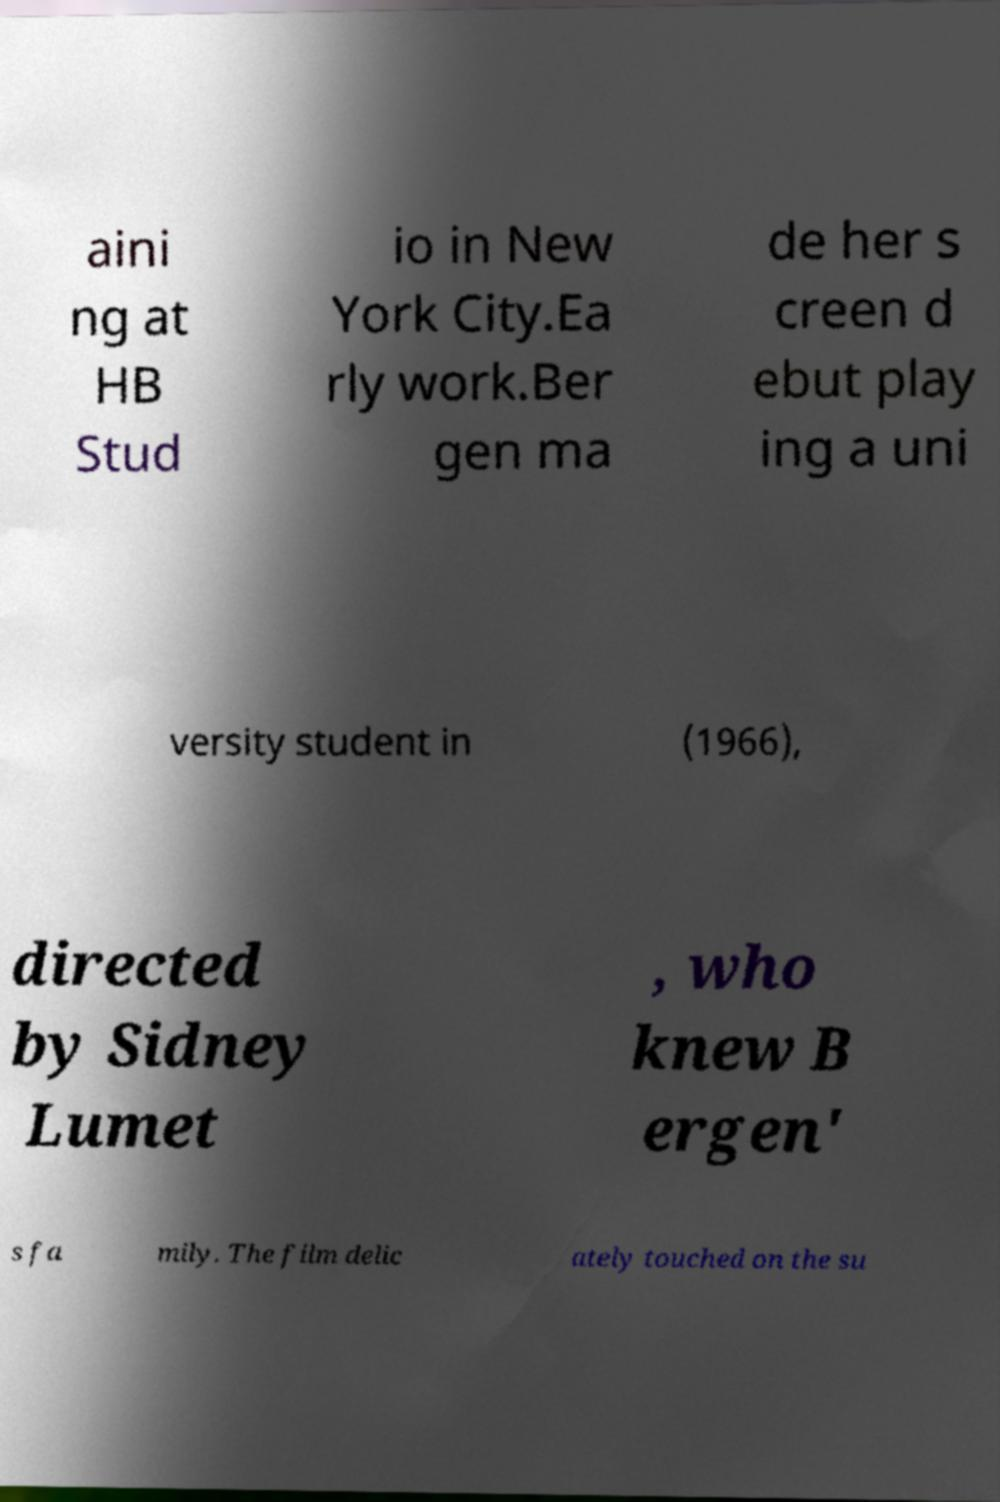Please identify and transcribe the text found in this image. aini ng at HB Stud io in New York City.Ea rly work.Ber gen ma de her s creen d ebut play ing a uni versity student in (1966), directed by Sidney Lumet , who knew B ergen' s fa mily. The film delic ately touched on the su 